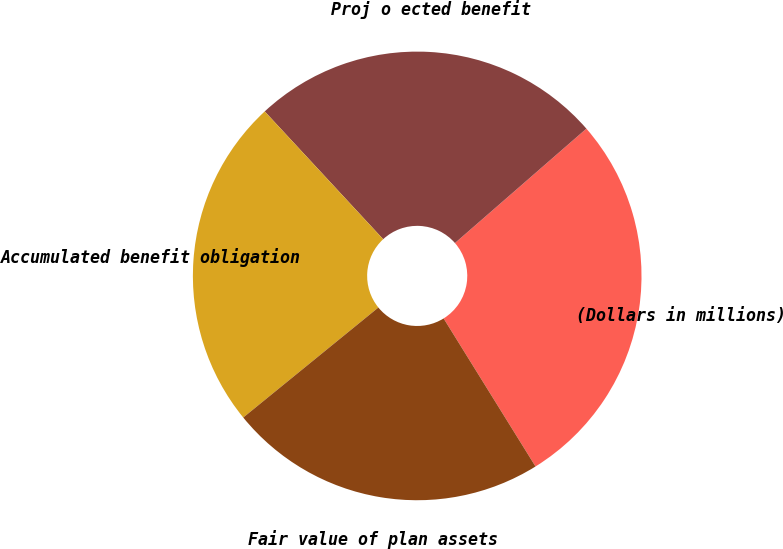Convert chart to OTSL. <chart><loc_0><loc_0><loc_500><loc_500><pie_chart><fcel>(Dollars in millions)<fcel>Proj o ected benefit<fcel>Accumulated benefit obligation<fcel>Fair value of plan assets<nl><fcel>27.56%<fcel>25.5%<fcel>23.98%<fcel>22.97%<nl></chart> 